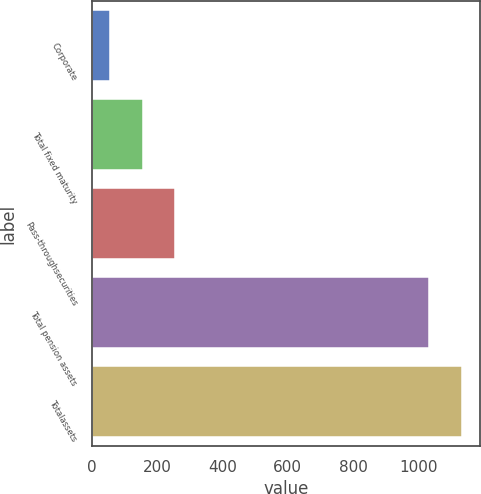Convert chart to OTSL. <chart><loc_0><loc_0><loc_500><loc_500><bar_chart><fcel>Corporate<fcel>Total fixed maturity<fcel>Pass-throughsecurities<fcel>Total pension assets<fcel>Totalassets<nl><fcel>57<fcel>155.9<fcel>254.8<fcel>1033<fcel>1131.9<nl></chart> 